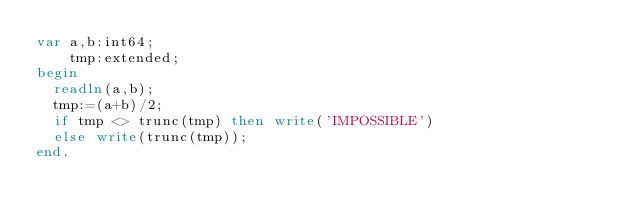Convert code to text. <code><loc_0><loc_0><loc_500><loc_500><_Pascal_>var a,b:int64;
    tmp:extended;
begin
	readln(a,b);
	tmp:=(a+b)/2;
	if tmp <> trunc(tmp) then write('IMPOSSIBLE')
	else write(trunc(tmp));
end.</code> 